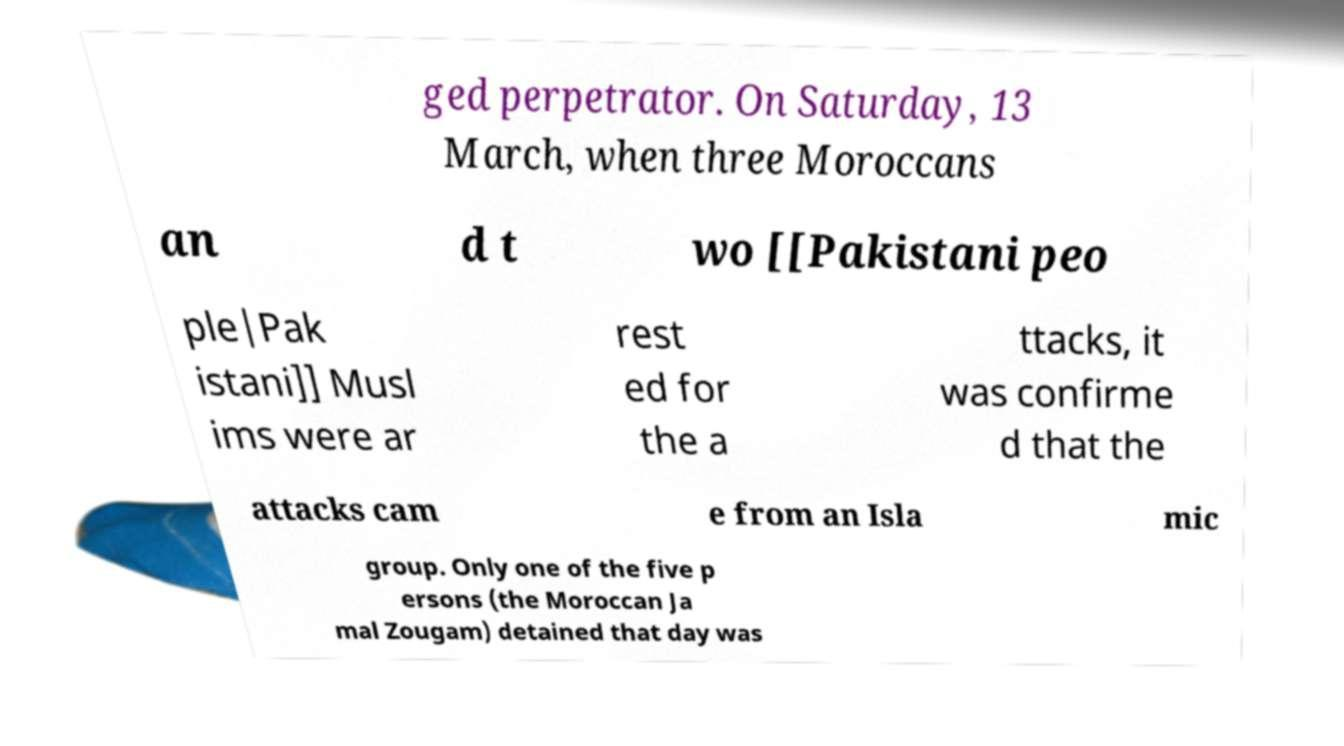Can you read and provide the text displayed in the image?This photo seems to have some interesting text. Can you extract and type it out for me? ged perpetrator. On Saturday, 13 March, when three Moroccans an d t wo [[Pakistani peo ple|Pak istani]] Musl ims were ar rest ed for the a ttacks, it was confirme d that the attacks cam e from an Isla mic group. Only one of the five p ersons (the Moroccan Ja mal Zougam) detained that day was 